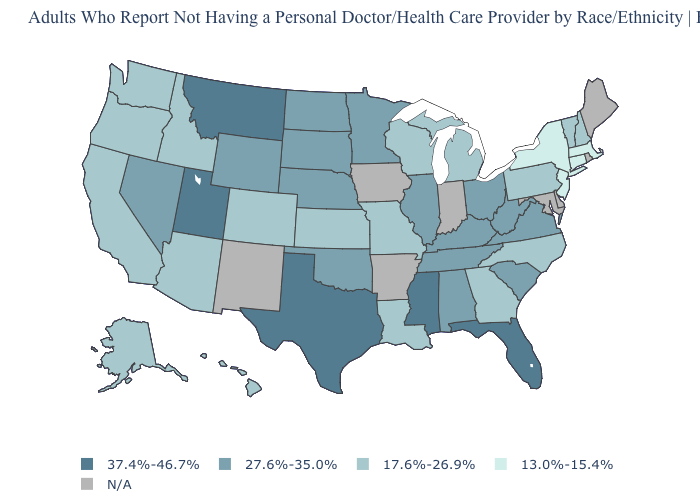Which states hav the highest value in the Northeast?
Quick response, please. New Hampshire, Pennsylvania, Vermont. Is the legend a continuous bar?
Be succinct. No. What is the value of Arizona?
Quick response, please. 17.6%-26.9%. Is the legend a continuous bar?
Give a very brief answer. No. Among the states that border Indiana , which have the highest value?
Short answer required. Illinois, Kentucky, Ohio. Name the states that have a value in the range 27.6%-35.0%?
Write a very short answer. Alabama, Illinois, Kentucky, Minnesota, Nebraska, Nevada, North Dakota, Ohio, Oklahoma, South Carolina, South Dakota, Tennessee, Virginia, West Virginia, Wyoming. Name the states that have a value in the range 37.4%-46.7%?
Quick response, please. Florida, Mississippi, Montana, Texas, Utah. Which states have the highest value in the USA?
Answer briefly. Florida, Mississippi, Montana, Texas, Utah. Name the states that have a value in the range 27.6%-35.0%?
Concise answer only. Alabama, Illinois, Kentucky, Minnesota, Nebraska, Nevada, North Dakota, Ohio, Oklahoma, South Carolina, South Dakota, Tennessee, Virginia, West Virginia, Wyoming. Is the legend a continuous bar?
Give a very brief answer. No. Name the states that have a value in the range 27.6%-35.0%?
Write a very short answer. Alabama, Illinois, Kentucky, Minnesota, Nebraska, Nevada, North Dakota, Ohio, Oklahoma, South Carolina, South Dakota, Tennessee, Virginia, West Virginia, Wyoming. Does the first symbol in the legend represent the smallest category?
Be succinct. No. What is the value of Georgia?
Quick response, please. 17.6%-26.9%. How many symbols are there in the legend?
Quick response, please. 5. 